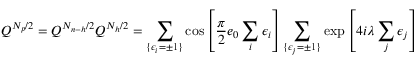<formula> <loc_0><loc_0><loc_500><loc_500>Q ^ { N _ { p } / 2 } = Q ^ { N _ { n - h } / 2 } Q ^ { N _ { h } / 2 } = \sum _ { \{ \epsilon _ { i } = \pm 1 \} } \cos \left [ \frac { \pi } { 2 } e _ { 0 } \sum _ { i } \epsilon _ { i } \right ] \sum _ { \{ \epsilon _ { j } = \pm 1 \} } \exp \left [ 4 i \lambda \sum _ { j } \epsilon _ { j } \right ]</formula> 